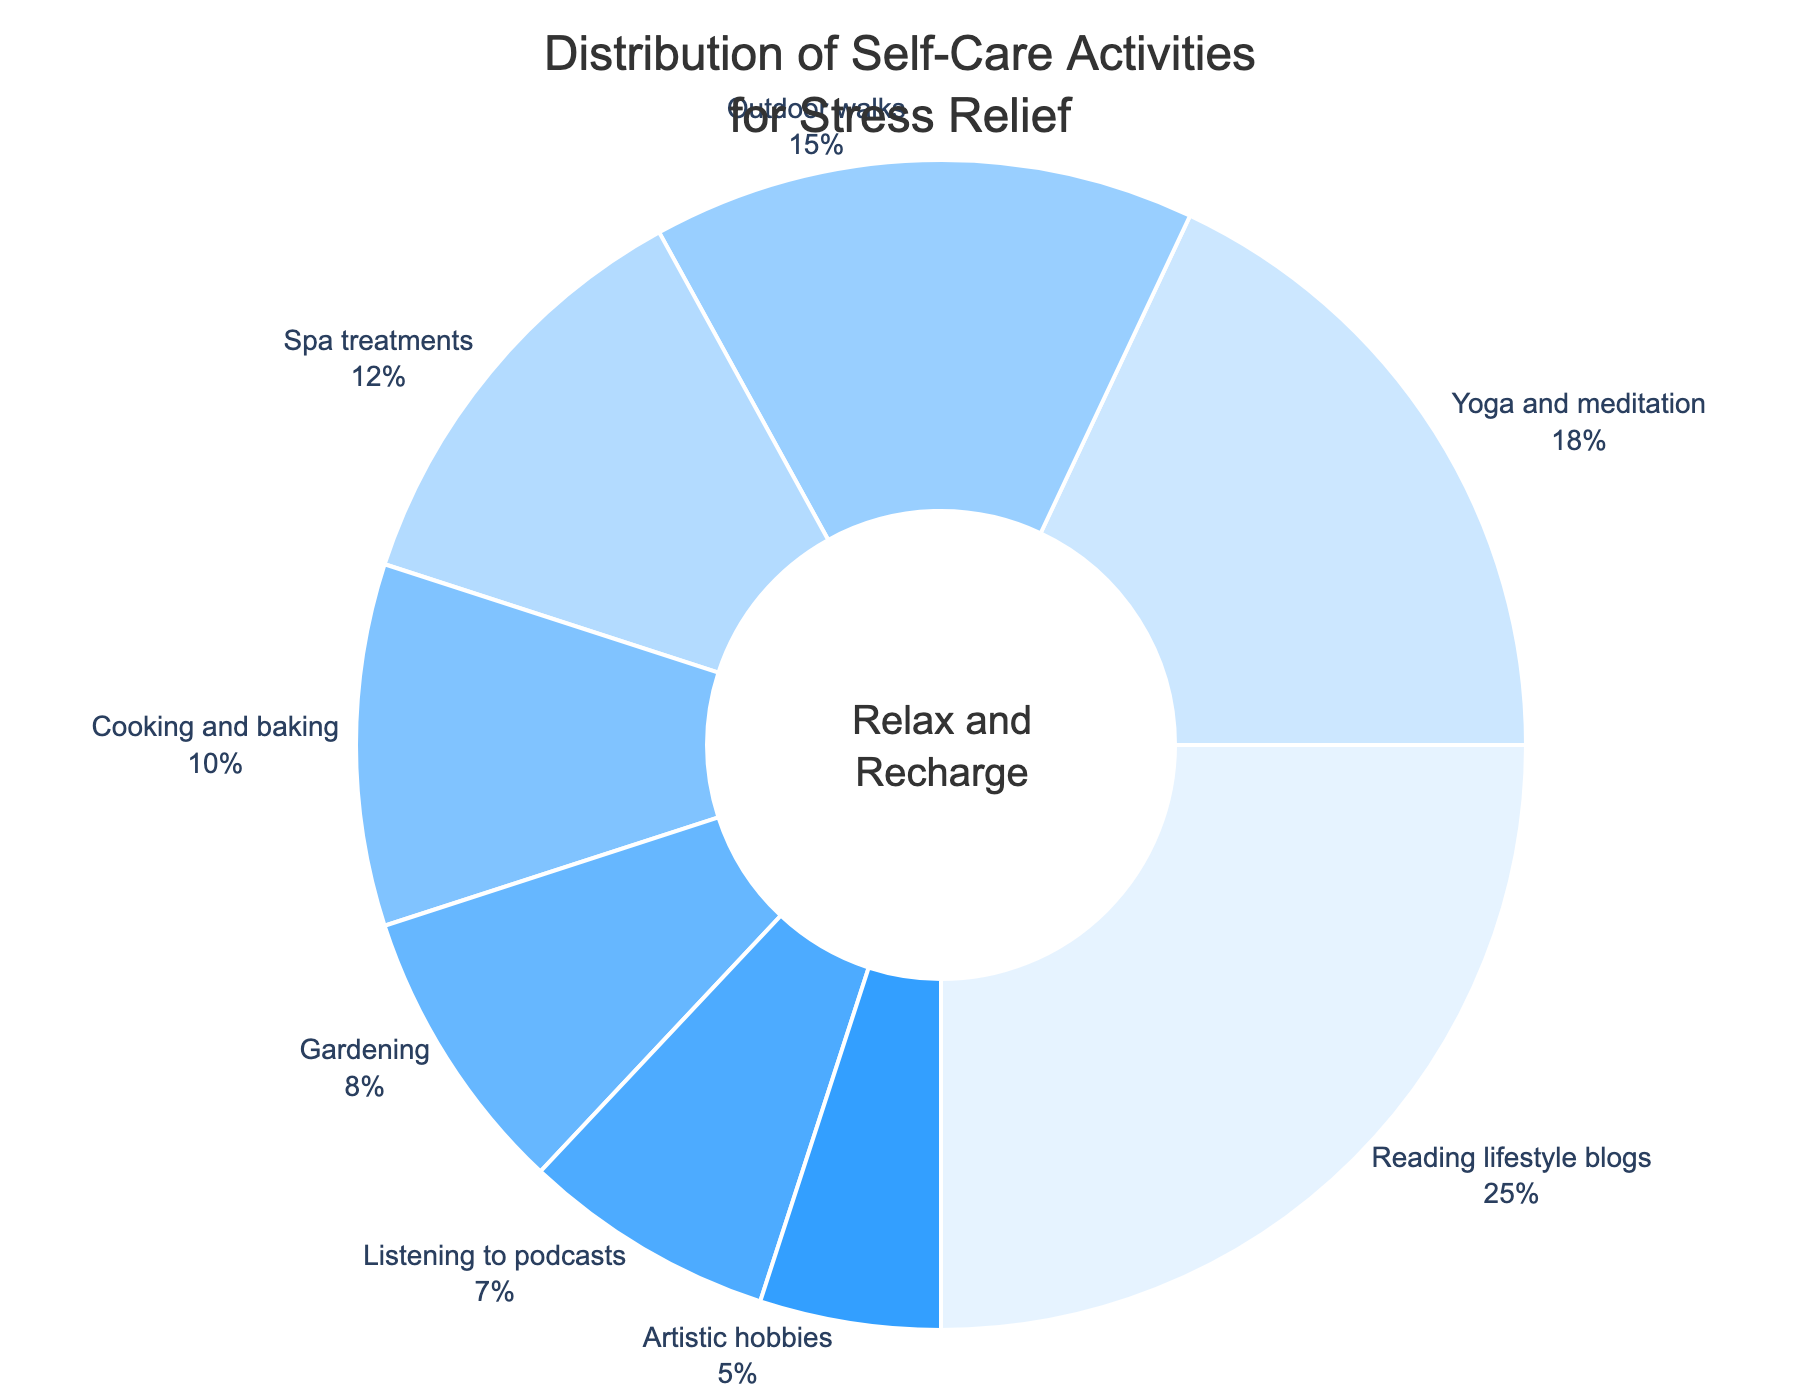What is the most popular self-care activity for stress relief among professionals? The figure shows the distribution of self-care activities and the one with the largest section is the most popular. "Reading lifestyle blogs" occupies the largest section with 25%.
Answer: Reading lifestyle blogs How much more popular is reading lifestyle blogs compared to yoga and meditation? The figure shows that "Reading lifestyle blogs" is 25% and "Yoga and meditation" is 18%. Subtract 18% from 25% to get the difference.
Answer: 7% Which activity is least popular among professionals for stress relief? The least popular activity will have the smallest section in the pie chart. "Artistic hobbies" occupies the smallest section with 5%.
Answer: Artistic hobbies What is the combined percentage of outdoor walks and cooking and baking? Identify the percentages for "Outdoor walks" and for "Cooking and baking" from the pie chart, which are 15% and 10% respectively. Add these percentages together.
Answer: 25% How many activities have a percentage greater than 10%? Review the pie chart and count the number of activities that have a section greater than 10%. The activities are "Reading lifestyle blogs", "Yoga and meditation", "Spa treatments", and "Outdoor walks", totaling 4 activities.
Answer: 4 By how much does the percentage of cooking and baking exceed artistic hobbies? Identify the percentages for “Cooking and baking” and “Artistic hobbies” from the pie chart, which are 10% and 5% respectively. Subtract 5% from 10% to get the difference.
Answer: 5% If you combine gardening and listening to podcasts, does their combined percentage exceed the percentage of yoga and meditation? From the pie chart, "Gardening" is 8% and "Listening to podcasts" is 7%. Their combined percentage is 8% + 7% = 15%, while "Yoga and meditation" is 18%. Since 15% is less than 18%, their combined percentage does not exceed yoga and meditation.
Answer: No Which self-care activities have a smaller percentage than spa treatments? Spa treatments have a percentage of 12%. Activities with smaller percentages are "Cooking and baking" (10%), "Gardening" (8%), "Listening to podcasts" (7%), and "Artistic hobbies" (5%).
Answer: Cooking and baking, Gardening, Listening to podcasts, Artistic hobbies What is the total percentage of the top three self-care activities? The top three self-care activities by percentage are "Reading lifestyle blogs" (25%), "Yoga and meditation" (18%), and "Outdoor walks" (15%). Add these percentages together.
Answer: 58% If professionals spend an equal amount of time on each activity, what percentage of time would be allocated to gardening and artistic hobbies combined? There are 8 activities in total. If time is equally divided among them, each activity gets 12.5%. Combining "Gardening" and "Artistic hobbies" would be 12.5% + 12.5%.
Answer: 25% 